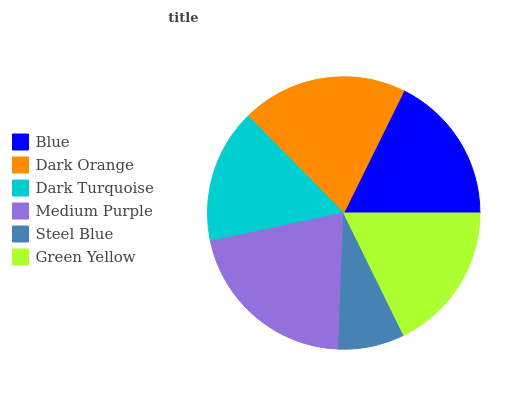Is Steel Blue the minimum?
Answer yes or no. Yes. Is Medium Purple the maximum?
Answer yes or no. Yes. Is Dark Orange the minimum?
Answer yes or no. No. Is Dark Orange the maximum?
Answer yes or no. No. Is Dark Orange greater than Blue?
Answer yes or no. Yes. Is Blue less than Dark Orange?
Answer yes or no. Yes. Is Blue greater than Dark Orange?
Answer yes or no. No. Is Dark Orange less than Blue?
Answer yes or no. No. Is Green Yellow the high median?
Answer yes or no. Yes. Is Blue the low median?
Answer yes or no. Yes. Is Blue the high median?
Answer yes or no. No. Is Medium Purple the low median?
Answer yes or no. No. 